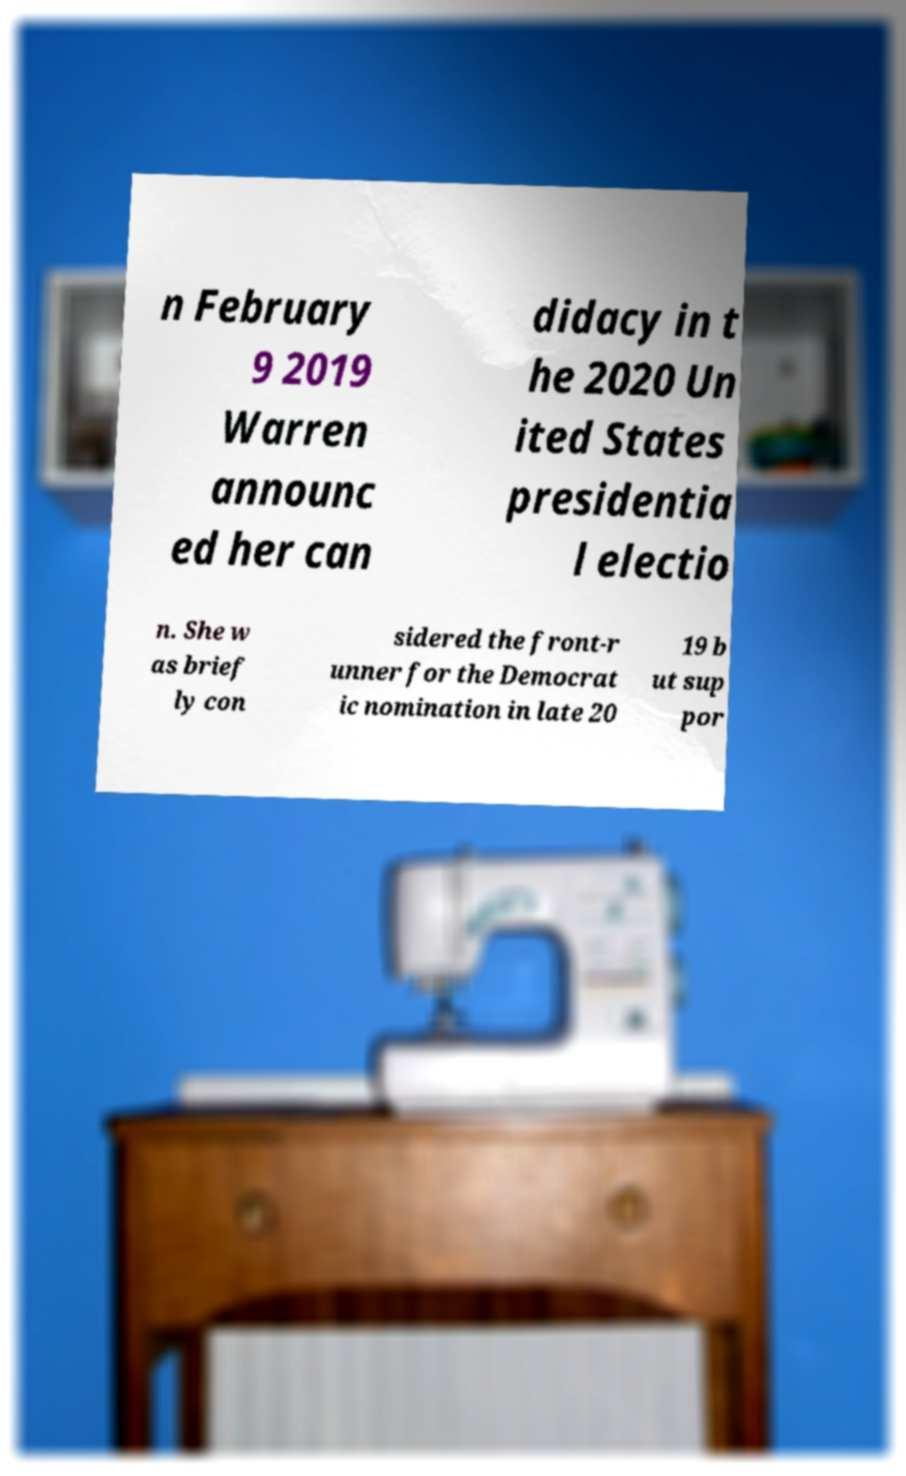Can you read and provide the text displayed in the image?This photo seems to have some interesting text. Can you extract and type it out for me? n February 9 2019 Warren announc ed her can didacy in t he 2020 Un ited States presidentia l electio n. She w as brief ly con sidered the front-r unner for the Democrat ic nomination in late 20 19 b ut sup por 